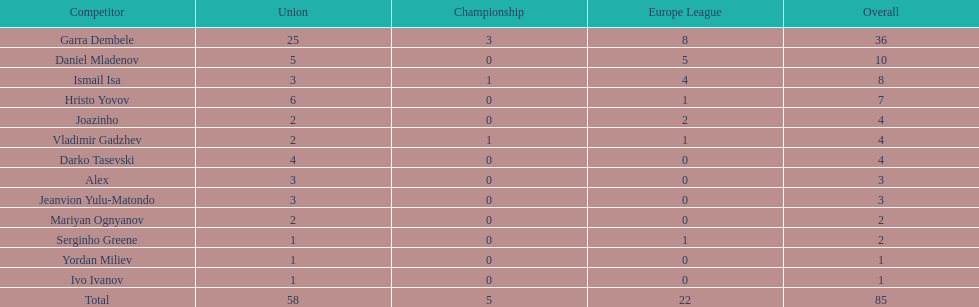Who was the top goalscorer on this team? Garra Dembele. 